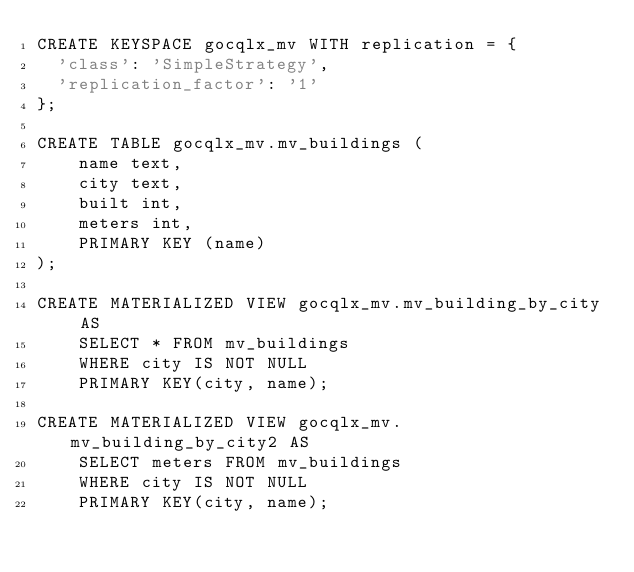<code> <loc_0><loc_0><loc_500><loc_500><_SQL_>CREATE KEYSPACE gocqlx_mv WITH replication = {
  'class': 'SimpleStrategy',
  'replication_factor': '1'
};

CREATE TABLE gocqlx_mv.mv_buildings (
    name text,
    city text,
    built int,
    meters int,
    PRIMARY KEY (name)
);

CREATE MATERIALIZED VIEW gocqlx_mv.mv_building_by_city AS
    SELECT * FROM mv_buildings
    WHERE city IS NOT NULL
    PRIMARY KEY(city, name);

CREATE MATERIALIZED VIEW gocqlx_mv.mv_building_by_city2 AS
    SELECT meters FROM mv_buildings
    WHERE city IS NOT NULL
    PRIMARY KEY(city, name);
</code> 